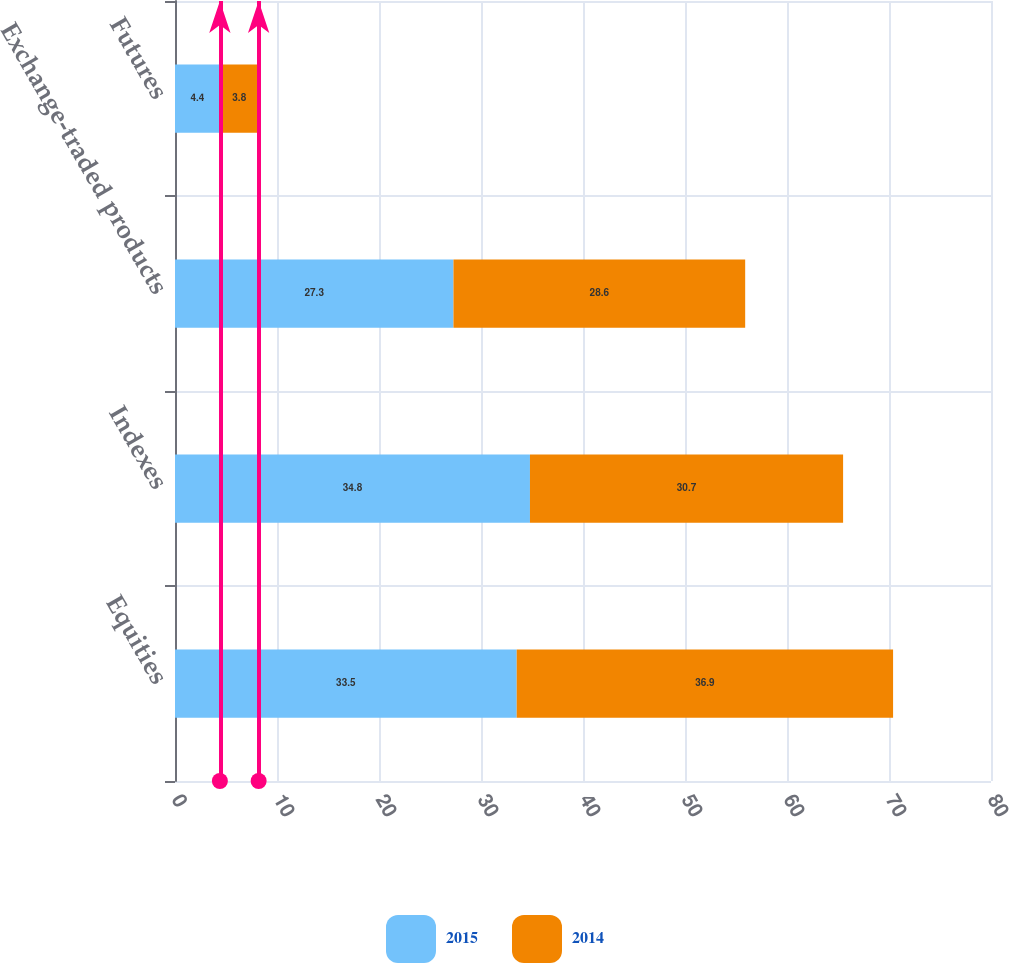<chart> <loc_0><loc_0><loc_500><loc_500><stacked_bar_chart><ecel><fcel>Equities<fcel>Indexes<fcel>Exchange-traded products<fcel>Futures<nl><fcel>2015<fcel>33.5<fcel>34.8<fcel>27.3<fcel>4.4<nl><fcel>2014<fcel>36.9<fcel>30.7<fcel>28.6<fcel>3.8<nl></chart> 